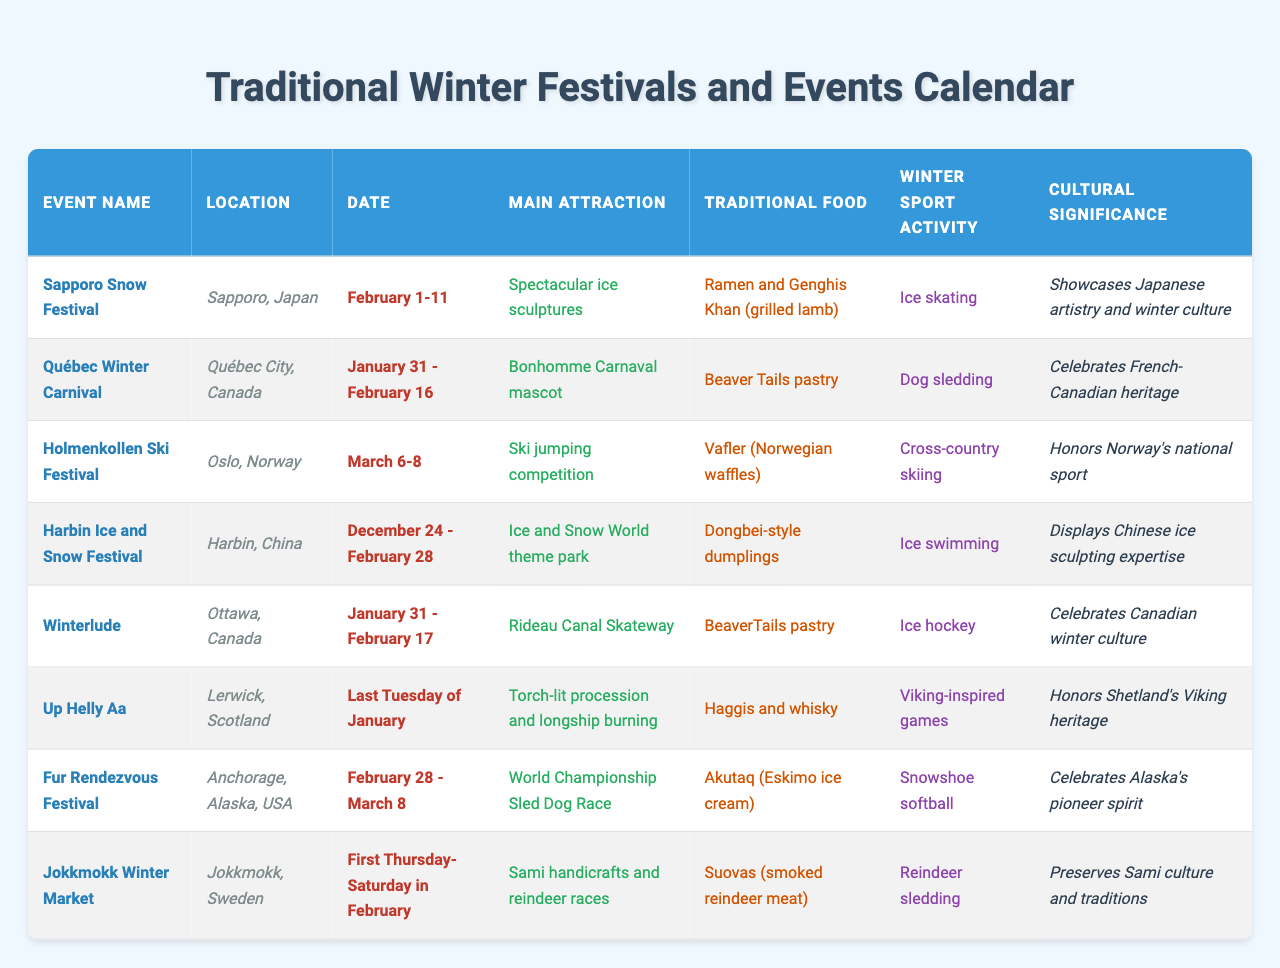What is the location of the Sapporo Snow Festival? The table shows the Sapporo Snow Festival located in Sapporo, Japan, under the Location column.
Answer: Sapporo, Japan What is the main attraction of the Québec Winter Carnival? According to the table, the main attraction of the Québec Winter Carnival is the Bonhomme Carnaval mascot, listed in the Main Attraction column.
Answer: Bonhomme Carnaval mascot Which event celebrates French-Canadian heritage? The table indicates that the Québec Winter Carnival specifically celebrates French-Canadian heritage under the Cultural Significance column.
Answer: Québec Winter Carnival What traditional food is associated with the Holmenkollen Ski Festival? The table lists Vafler (Norwegian waffles) as the traditional food for the Holmenkollen Ski Festival in the Traditional Food column.
Answer: Vafler (Norwegian waffles) How many days does the Harbin Ice and Snow Festival last? The table states that the Harbin Ice and Snow Festival runs from December 24 to February 28, which totals 67 days when counted inclusively.
Answer: 67 days Which winter sport activity is common to both the Winterlude and the Fur Rendezvous Festival? The table shows that both events include dog sledding as a winter sport activity in their respective activity columns.
Answer: Dog sledding Is the Up Helly Aa event held in January? The data in the table confirms that the Up Helly Aa event occurs on the last Tuesday of January, thus affirming that it is indeed held in that month.
Answer: Yes What is the cultural significance of the Jokkmokk Winter Market? The table indicates that the Jokkmokk Winter Market preserves Sami culture and traditions, as stated in the Cultural Significance column.
Answer: Preserves Sami culture and traditions Which two events take place in the same period? According to the Date column, both Winterlude and the Québec Winter Carnival take place between January 31 and February 17.
Answer: Winterlude and Québec Winter Carnival Can you list all the traditional foods from the events held in Canada? Referring to the table, the traditional foods from events in Canada are Beaver Tails pastries for both the Québec Winter Carnival and Winterlude, so both events share the same traditional food.
Answer: Beaver Tails pastries 